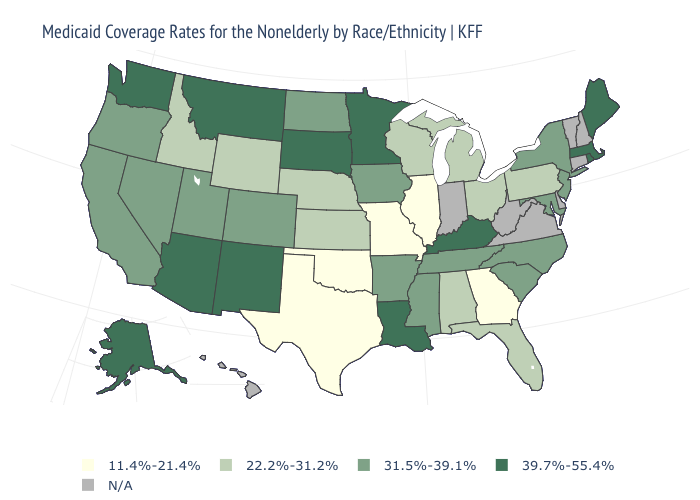What is the value of Utah?
Quick response, please. 31.5%-39.1%. What is the value of Wyoming?
Answer briefly. 22.2%-31.2%. Name the states that have a value in the range N/A?
Keep it brief. Connecticut, Delaware, Hawaii, Indiana, New Hampshire, Vermont, Virginia, West Virginia. Which states have the lowest value in the USA?
Concise answer only. Georgia, Illinois, Missouri, Oklahoma, Texas. What is the value of Idaho?
Be succinct. 22.2%-31.2%. Which states have the lowest value in the USA?
Give a very brief answer. Georgia, Illinois, Missouri, Oklahoma, Texas. Which states have the highest value in the USA?
Concise answer only. Alaska, Arizona, Kentucky, Louisiana, Maine, Massachusetts, Minnesota, Montana, New Mexico, Rhode Island, South Dakota, Washington. Name the states that have a value in the range 22.2%-31.2%?
Concise answer only. Alabama, Florida, Idaho, Kansas, Michigan, Nebraska, Ohio, Pennsylvania, Wisconsin, Wyoming. What is the value of Maryland?
Be succinct. 31.5%-39.1%. Name the states that have a value in the range 39.7%-55.4%?
Keep it brief. Alaska, Arizona, Kentucky, Louisiana, Maine, Massachusetts, Minnesota, Montana, New Mexico, Rhode Island, South Dakota, Washington. Does Kentucky have the lowest value in the USA?
Answer briefly. No. What is the lowest value in states that border Massachusetts?
Be succinct. 31.5%-39.1%. What is the value of Mississippi?
Short answer required. 31.5%-39.1%. Does New York have the highest value in the Northeast?
Short answer required. No. 